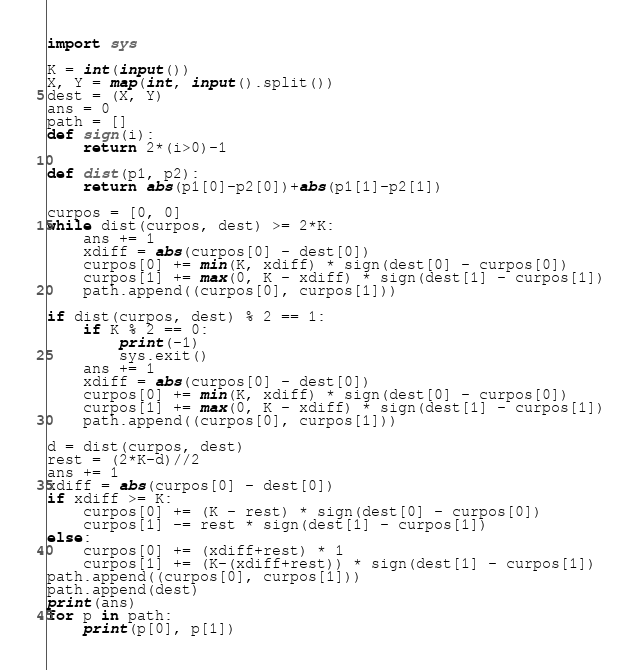Convert code to text. <code><loc_0><loc_0><loc_500><loc_500><_Python_>import sys

K = int(input())
X, Y = map(int, input().split())
dest = (X, Y)
ans = 0
path = []
def sign(i):
    return 2*(i>0)-1

def dist(p1, p2):
    return abs(p1[0]-p2[0])+abs(p1[1]-p2[1])

curpos = [0, 0]
while dist(curpos, dest) >= 2*K:
    ans += 1
    xdiff = abs(curpos[0] - dest[0])
    curpos[0] += min(K, xdiff) * sign(dest[0] - curpos[0])
    curpos[1] += max(0, K - xdiff) * sign(dest[1] - curpos[1])
    path.append((curpos[0], curpos[1]))

if dist(curpos, dest) % 2 == 1:
    if K % 2 == 0:
        print(-1)
        sys.exit()
    ans += 1
    xdiff = abs(curpos[0] - dest[0])
    curpos[0] += min(K, xdiff) * sign(dest[0] - curpos[0])
    curpos[1] += max(0, K - xdiff) * sign(dest[1] - curpos[1])
    path.append((curpos[0], curpos[1]))

d = dist(curpos, dest)
rest = (2*K-d)//2
ans += 1
xdiff = abs(curpos[0] - dest[0])
if xdiff >= K:
    curpos[0] += (K - rest) * sign(dest[0] - curpos[0])
    curpos[1] -= rest * sign(dest[1] - curpos[1])
else:
    curpos[0] += (xdiff+rest) * 1
    curpos[1] += (K-(xdiff+rest)) * sign(dest[1] - curpos[1])
path.append((curpos[0], curpos[1]))
path.append(dest)
print(ans)
for p in path:
    print(p[0], p[1])
</code> 